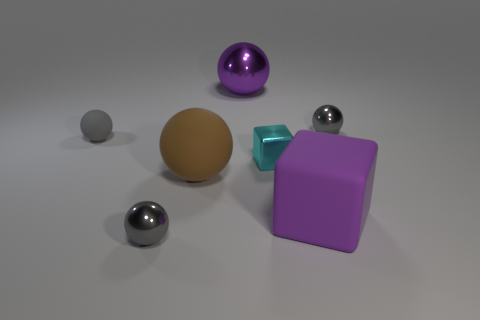Are there an equal number of tiny gray balls that are behind the cyan metal thing and gray metal balls?
Give a very brief answer. Yes. Do the purple cube and the brown matte thing have the same size?
Your answer should be very brief. Yes. There is a ball that is both on the left side of the big matte cube and behind the small gray rubber sphere; what color is it?
Give a very brief answer. Purple. What material is the big purple object in front of the gray metallic ball behind the cyan cube made of?
Offer a terse response. Rubber. There is a gray rubber object that is the same shape as the large metallic object; what size is it?
Your answer should be very brief. Small. There is a tiny shiny thing that is on the left side of the big purple sphere; does it have the same color as the tiny rubber object?
Offer a terse response. Yes. Are there fewer tiny gray metallic balls than rubber objects?
Make the answer very short. Yes. How many other things are the same color as the metal cube?
Offer a terse response. 0. Do the gray sphere that is to the right of the purple shiny object and the cyan object have the same material?
Make the answer very short. Yes. What is the small gray sphere that is in front of the large purple matte cube made of?
Make the answer very short. Metal. 